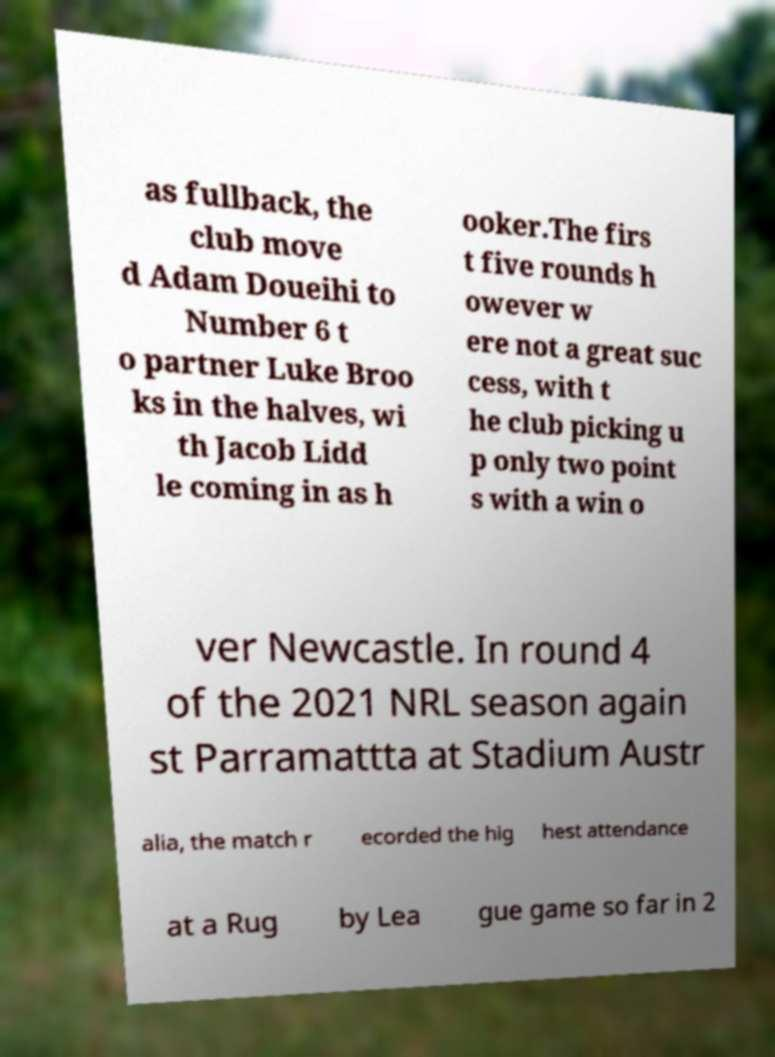What messages or text are displayed in this image? I need them in a readable, typed format. as fullback, the club move d Adam Doueihi to Number 6 t o partner Luke Broo ks in the halves, wi th Jacob Lidd le coming in as h ooker.The firs t five rounds h owever w ere not a great suc cess, with t he club picking u p only two point s with a win o ver Newcastle. In round 4 of the 2021 NRL season again st Parramattta at Stadium Austr alia, the match r ecorded the hig hest attendance at a Rug by Lea gue game so far in 2 